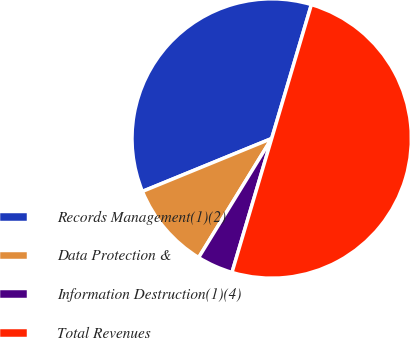Convert chart. <chart><loc_0><loc_0><loc_500><loc_500><pie_chart><fcel>Records Management(1)(2)<fcel>Data Protection &<fcel>Information Destruction(1)(4)<fcel>Total Revenues<nl><fcel>35.77%<fcel>10.06%<fcel>4.17%<fcel>50.0%<nl></chart> 